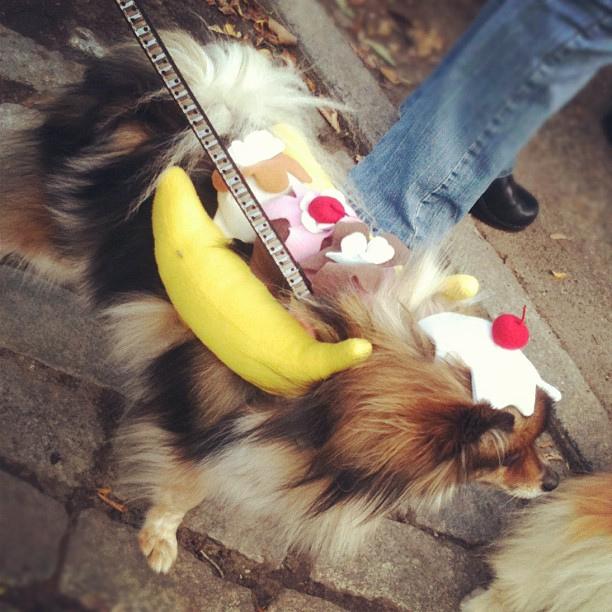Is it a sundae or a dog?
Quick response, please. Dog. Is this dog neglected?
Answer briefly. No. Where are the cherries?
Short answer required. On dog. 